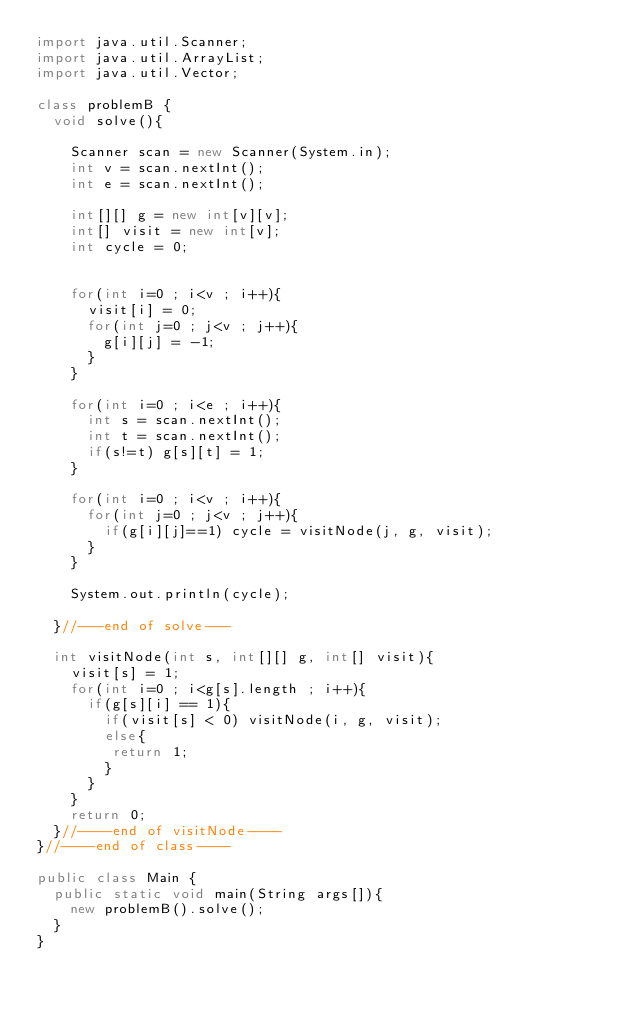Convert code to text. <code><loc_0><loc_0><loc_500><loc_500><_Java_>import java.util.Scanner;
import java.util.ArrayList;
import java.util.Vector;

class problemB {
  void solve(){

    Scanner scan = new Scanner(System.in);
    int v = scan.nextInt();
    int e = scan.nextInt();

    int[][] g = new int[v][v];
    int[] visit = new int[v];
    int cycle = 0;


    for(int i=0 ; i<v ; i++){
      visit[i] = 0;
      for(int j=0 ; j<v ; j++){
        g[i][j] = -1;
      }
    }

    for(int i=0 ; i<e ; i++){
      int s = scan.nextInt();
      int t = scan.nextInt();
      if(s!=t) g[s][t] = 1;
    }

    for(int i=0 ; i<v ; i++){
      for(int j=0 ; j<v ; j++){
        if(g[i][j]==1) cycle = visitNode(j, g, visit);
      }
    }

    System.out.println(cycle);

  }//---end of solve---

  int visitNode(int s, int[][] g, int[] visit){
    visit[s] = 1;
    for(int i=0 ; i<g[s].length ; i++){
      if(g[s][i] == 1){
        if(visit[s] < 0) visitNode(i, g, visit);
        else{
         return 1;
        }
      }
    }
    return 0;
  }//----end of visitNode----
}//----end of class----

public class Main {
  public static void main(String args[]){
    new problemB().solve();
  }
}

</code> 